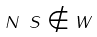Convert formula to latex. <formula><loc_0><loc_0><loc_500><loc_500>N \ S \notin W</formula> 